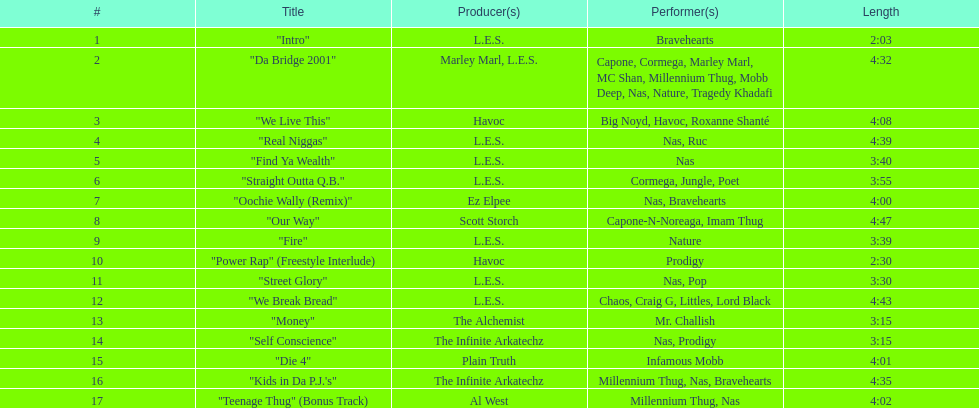What is the duration of the longest track on the list? 4:47. 